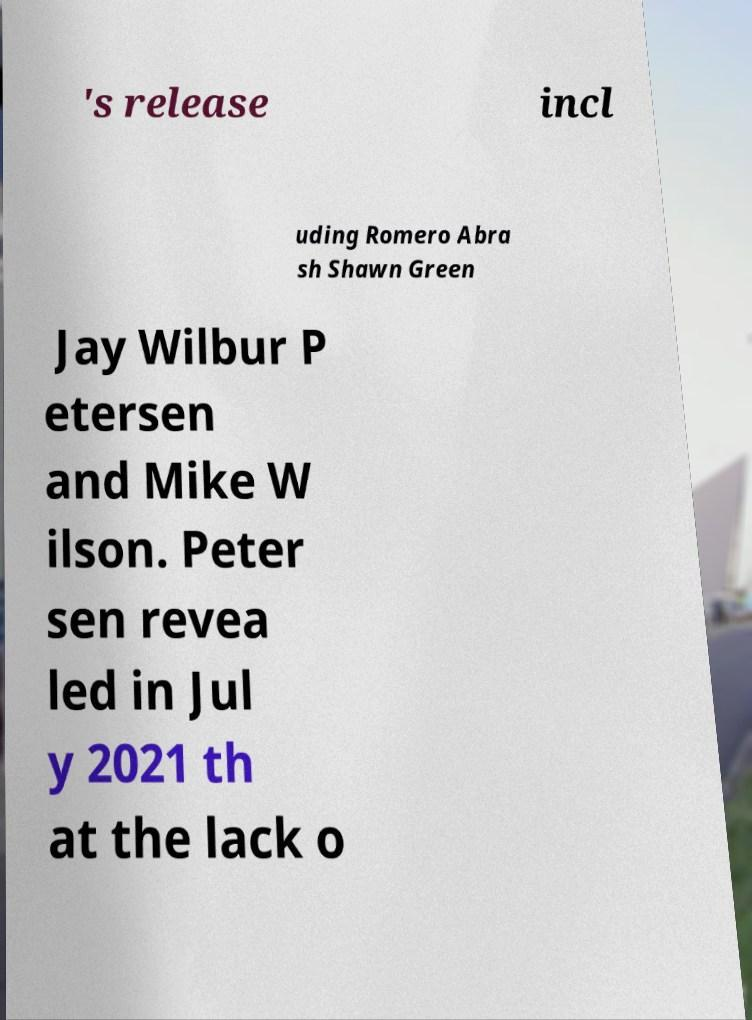There's text embedded in this image that I need extracted. Can you transcribe it verbatim? 's release incl uding Romero Abra sh Shawn Green Jay Wilbur P etersen and Mike W ilson. Peter sen revea led in Jul y 2021 th at the lack o 